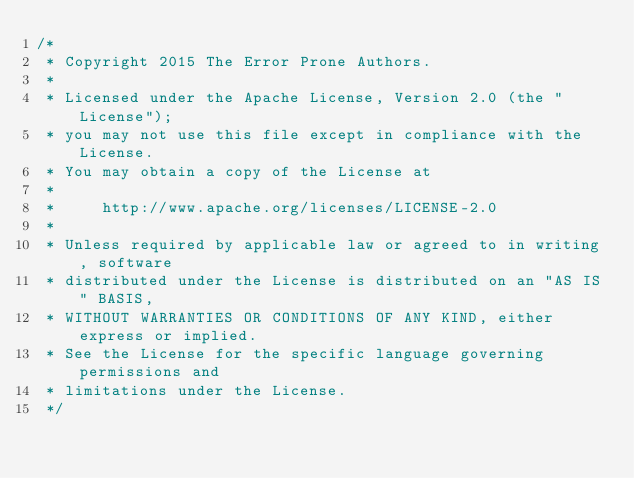Convert code to text. <code><loc_0><loc_0><loc_500><loc_500><_Java_>/*
 * Copyright 2015 The Error Prone Authors.
 *
 * Licensed under the Apache License, Version 2.0 (the "License");
 * you may not use this file except in compliance with the License.
 * You may obtain a copy of the License at
 *
 *     http://www.apache.org/licenses/LICENSE-2.0
 *
 * Unless required by applicable law or agreed to in writing, software
 * distributed under the License is distributed on an "AS IS" BASIS,
 * WITHOUT WARRANTIES OR CONDITIONS OF ANY KIND, either express or implied.
 * See the License for the specific language governing permissions and
 * limitations under the License.
 */
</code> 